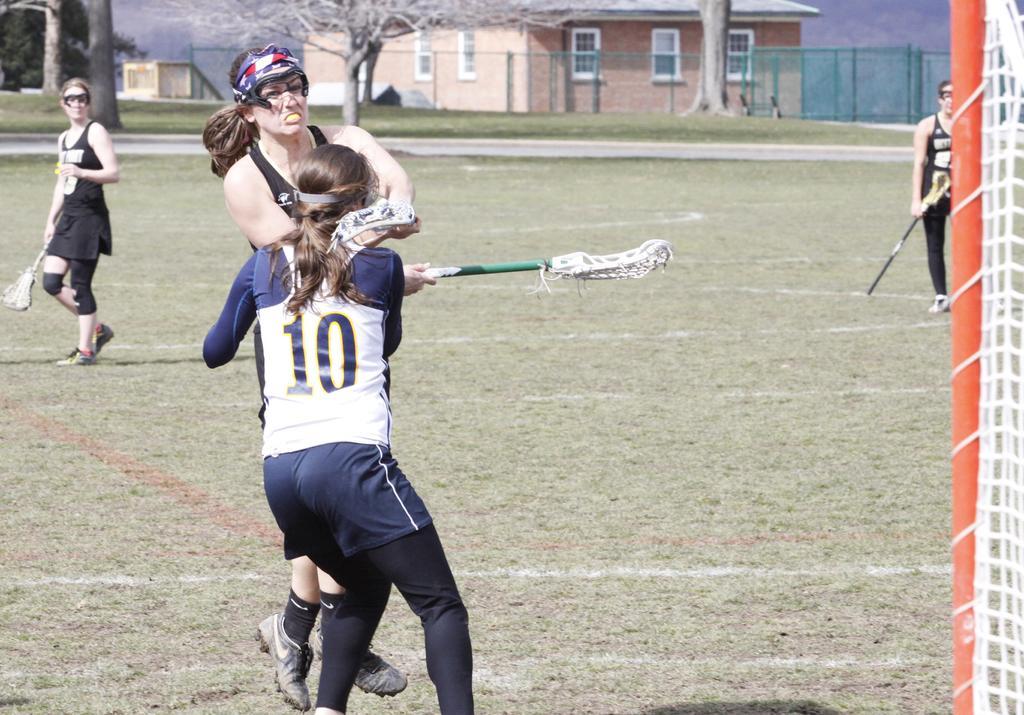How would you summarize this image in a sentence or two? In the middle of the image few people are standing and holding sticks. Behind them there are some trees and grass. Behind the trees there is fencing. At the top of the image there are some buildings. 